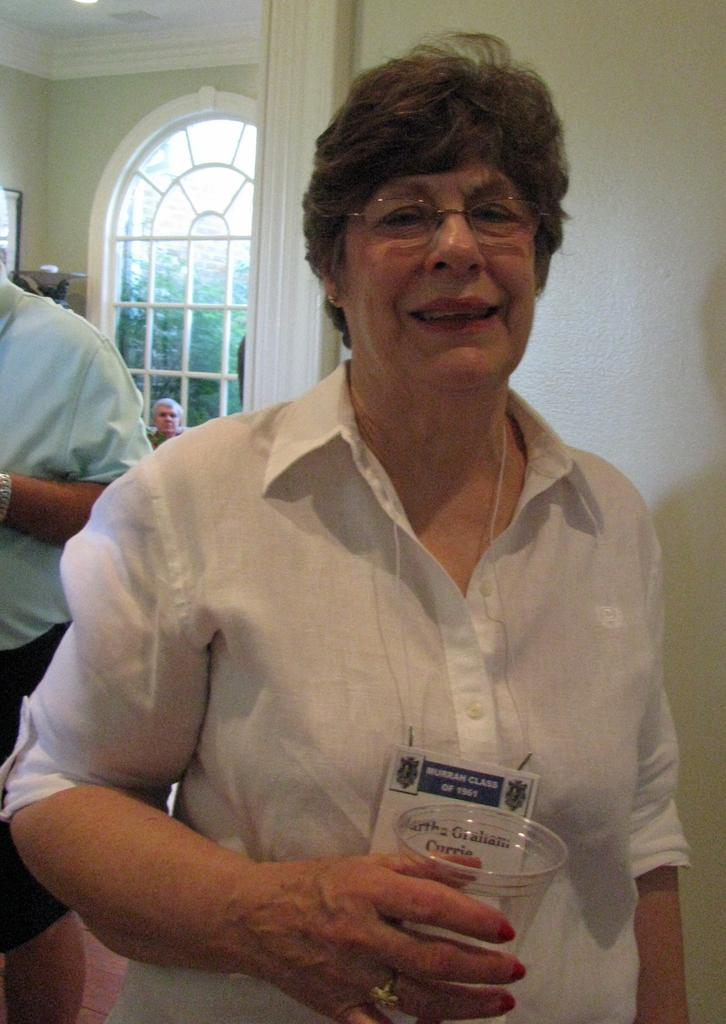What is the main subject of the image? The main subject of the image is a group of people. Can you describe the woman in the middle of the image? The woman in the middle of the image is wearing spectacles and holding a glass. What can be seen in the background of the image? There are trees visible in the background of the image. Reasoning: Let's think step by following the guidelines to produce the conversation. We start by identifying the main subject of the image, which is a group of people. Then, we focus on the woman in the middle of the image and describe her appearance and actions. Finally, we mention the background of the image, which includes trees. Absurd Question/Answer: How many fangs does the woman have in the image? The woman in the image is not depicted as having fangs, as she is a regular person wearing spectacles and holding a glass. How many hands does the woman have in the image? The woman in the image has two hands, as she is a regular person and not depicted with any additional limbs or appendages. 